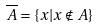Convert formula to latex. <formula><loc_0><loc_0><loc_500><loc_500>\overline { A } = \{ x | x \notin A \}</formula> 